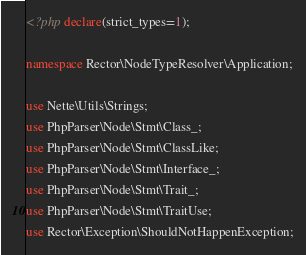Convert code to text. <code><loc_0><loc_0><loc_500><loc_500><_PHP_><?php declare(strict_types=1);

namespace Rector\NodeTypeResolver\Application;

use Nette\Utils\Strings;
use PhpParser\Node\Stmt\Class_;
use PhpParser\Node\Stmt\ClassLike;
use PhpParser\Node\Stmt\Interface_;
use PhpParser\Node\Stmt\Trait_;
use PhpParser\Node\Stmt\TraitUse;
use Rector\Exception\ShouldNotHappenException;</code> 